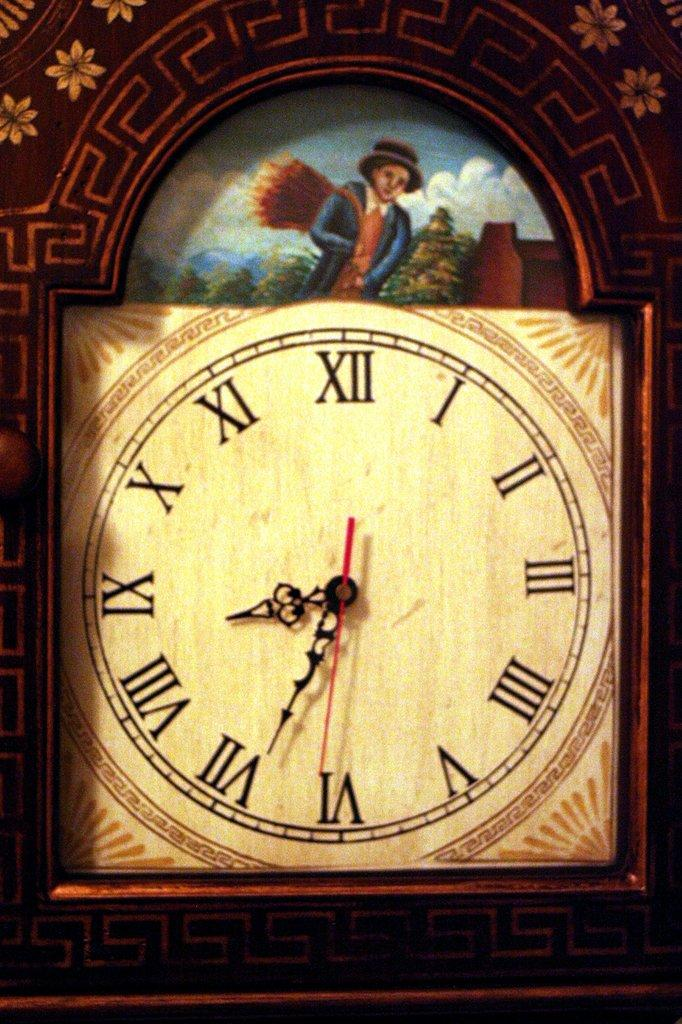<image>
Relay a brief, clear account of the picture shown. A clock with roman numerals that shows it being 8:34. 